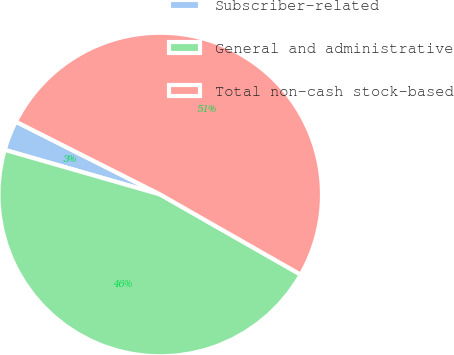Convert chart. <chart><loc_0><loc_0><loc_500><loc_500><pie_chart><fcel>Subscriber-related<fcel>General and administrative<fcel>Total non-cash stock-based<nl><fcel>2.99%<fcel>46.2%<fcel>50.82%<nl></chart> 